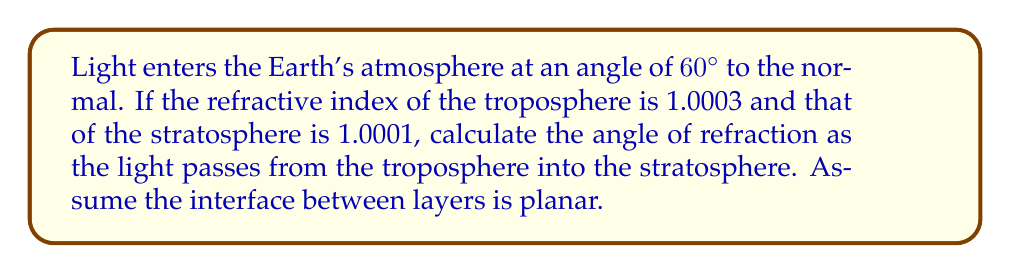Show me your answer to this math problem. Let's approach this step-by-step using Snell's law:

1) Snell's law states: $n_1 \sin \theta_1 = n_2 \sin \theta_2$

   Where:
   $n_1$ = refractive index of medium 1 (troposphere)
   $n_2$ = refractive index of medium 2 (stratosphere)
   $\theta_1$ = angle of incidence
   $\theta_2$ = angle of refraction (what we're solving for)

2) We're given:
   $n_1 = 1.0003$
   $n_2 = 1.0001$
   $\theta_1 = 60°$

3) Substituting into Snell's law:

   $1.0003 \sin 60° = 1.0001 \sin \theta_2$

4) Simplify the left side:
   $1.0003 \cdot 0.8660 = 1.0001 \sin \theta_2$
   $0.8663 = 1.0001 \sin \theta_2$

5) Solve for $\theta_2$:
   $$\sin \theta_2 = \frac{0.8663}{1.0001}$$
   $$\theta_2 = \arcsin(\frac{0.8663}{1.0001})$$

6) Calculate:
   $$\theta_2 \approx 60.0115°$$

The slight increase in angle is consistent with the light moving from a more optically dense medium to a less dense one, as expected for a pessimistic physicist observing atmospheric phenomena.
Answer: $60.0115°$ 